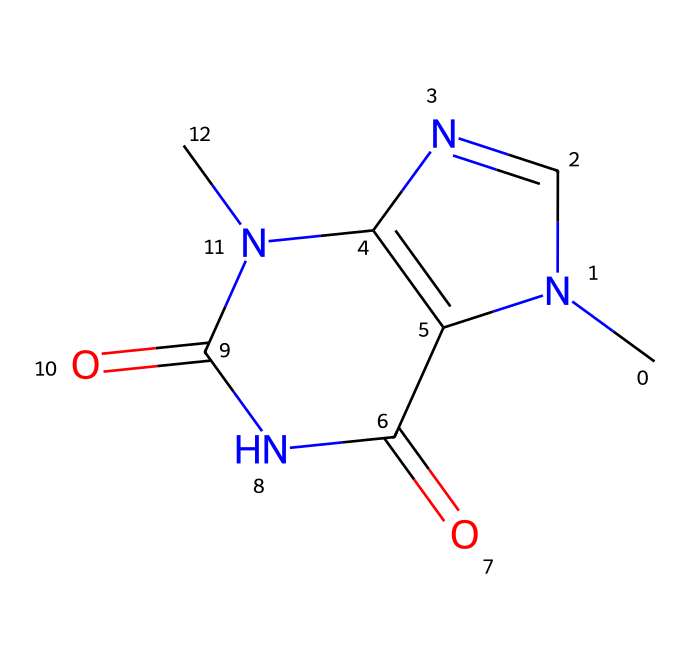What is the molecular formula of theobromine? To find the molecular formula, we need to count the number of carbon (C), hydrogen (H), nitrogen (N), and oxygen (O) atoms present in the chemical structure represented by the SMILES. In this case, there are 7 carbon atoms, 8 hydrogen atoms, 4 nitrogen atoms, and 2 oxygen atoms, leading to the formula C7H8N4O2.
Answer: C7H8N4O2 How many nitrogen atoms are in theobromine? By examining the SMILES representation, we look for 'N' characters that signify nitrogen atoms in the structure. There are a total of 4 'N' present in the structure.
Answer: 4 What type of chemical compound is theobromine? Theobromine is classified as an alkaloid, which is a type of naturally occurring organic compound that mostly contains basic nitrogen atoms. This classification is inferred from its structure, with the presence of multiple nitrogen atoms.
Answer: alkaloid Does theobromine contain any double bonds? We analyze the chemical structure to identify the bonds, specifically looking for any 'double bond' indicators which are shown as '=' in chemical notation. The structure contains multiple double bonds, particularly between carbon and nitrogen atoms.
Answer: yes Are there any ring structures present in theobromine? Upon inspecting the SMILES, we identify if there are any cyclic components, indicated by the numbers that show where rings close. In this structure, there are indeed closed rings formed by the connections of atoms referenced by the numbers.
Answer: yes What is the primary source of theobromine? Theobromine is primarily sourced from the cacao bean, which is used to make chocolate, a favorite snack for many, including book lovers who enjoy reading alongside their treats. This is based on the known extraction of theobromine from chocolate products.
Answer: cacao bean 